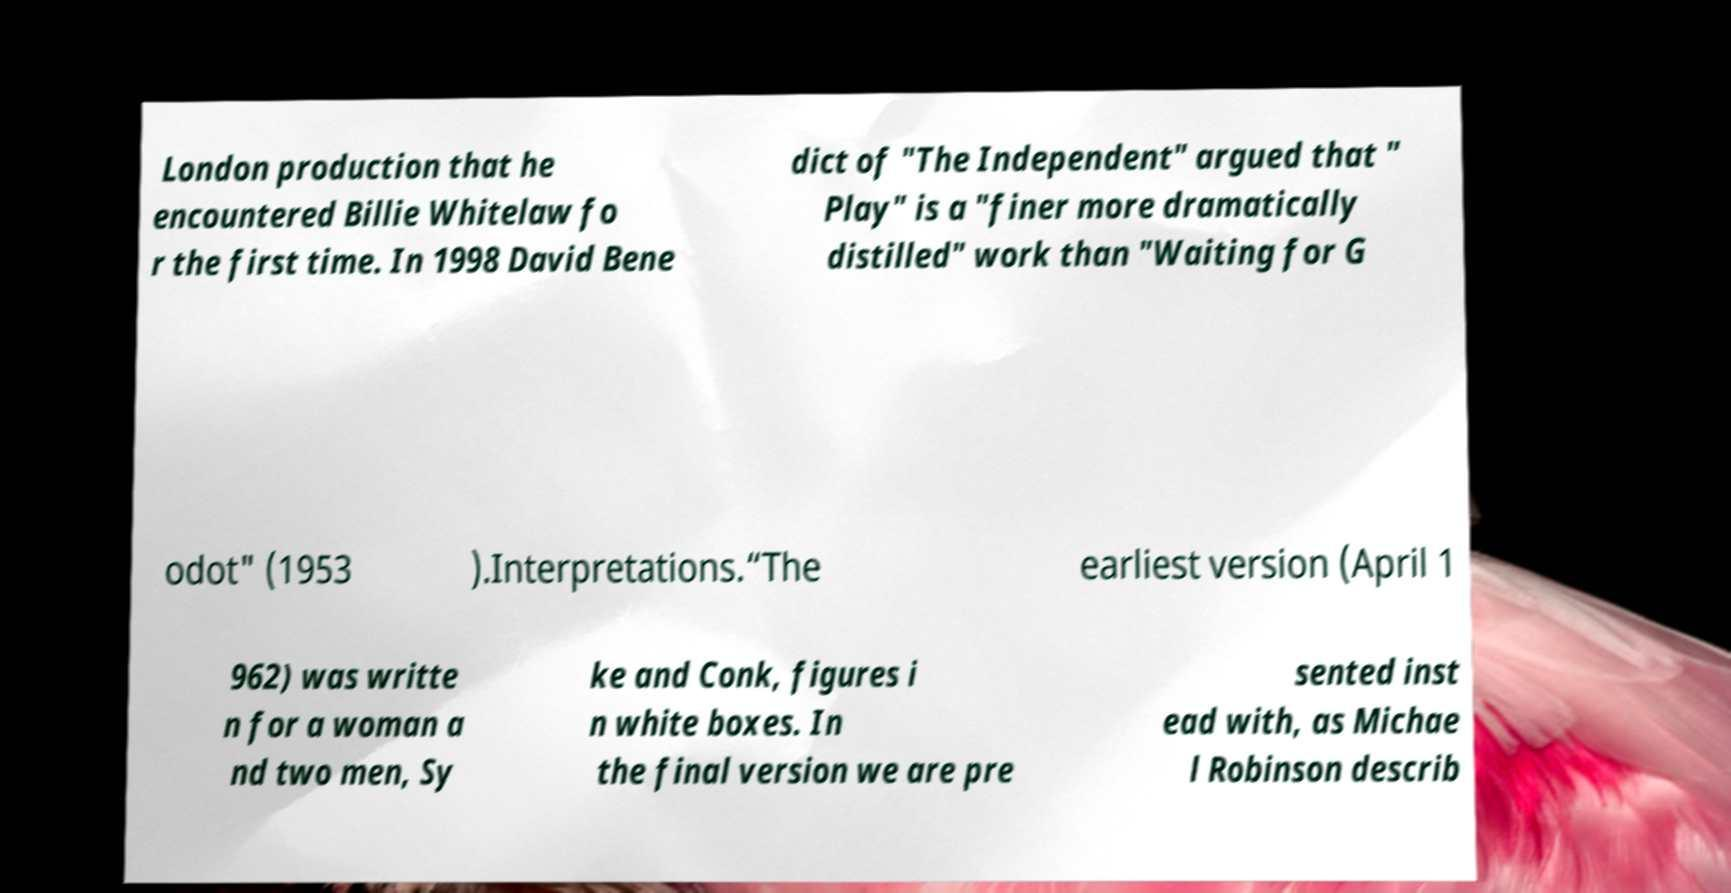Please identify and transcribe the text found in this image. London production that he encountered Billie Whitelaw fo r the first time. In 1998 David Bene dict of "The Independent" argued that " Play" is a "finer more dramatically distilled" work than "Waiting for G odot" (1953 ).Interpretations.“The earliest version (April 1 962) was writte n for a woman a nd two men, Sy ke and Conk, figures i n white boxes. In the final version we are pre sented inst ead with, as Michae l Robinson describ 